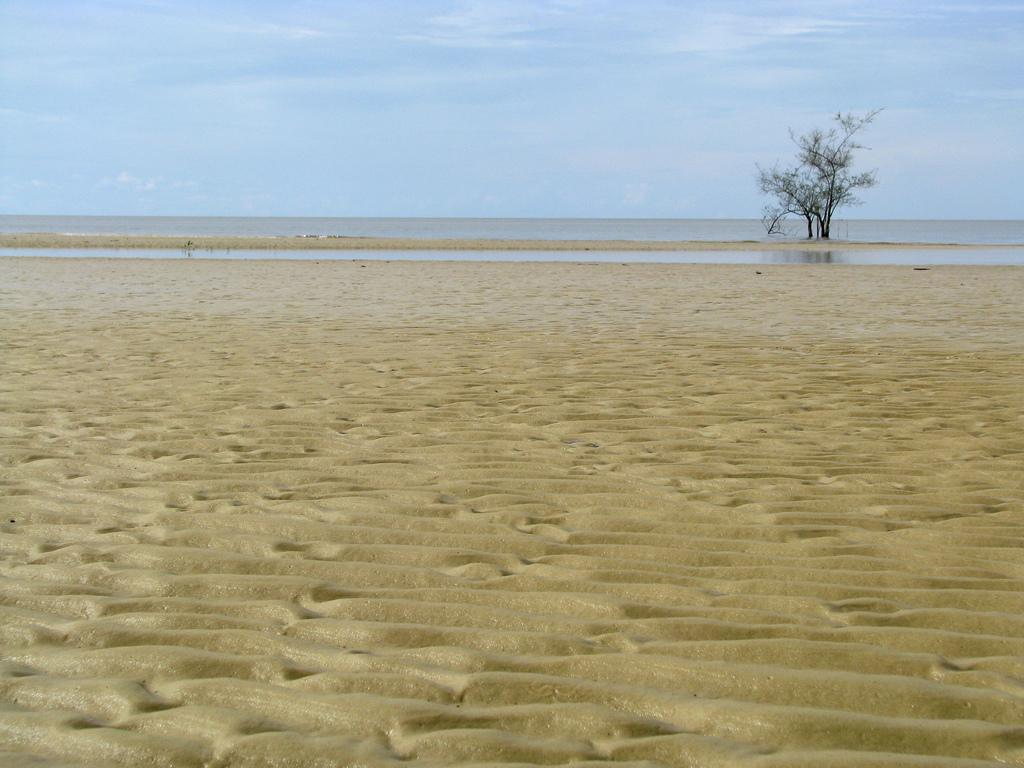What type of terrain is depicted in the image? There is a vast sandy land in the image. What can be seen in the background of the image? There is a tree and water in the background of the image. What is visible at the top of the image? The sky is visible at the top of the image. What can be observed in the sky? Clouds are present in the sky. What type of lipstick is the tree wearing in the image? There is no lipstick or tree wearing lipstick in the image; it features a tree in the background of a sandy landscape. What type of pancake can be seen floating in the water in the image? There is no pancake present in the image; it features a tree and water in the background of a sandy landscape. 